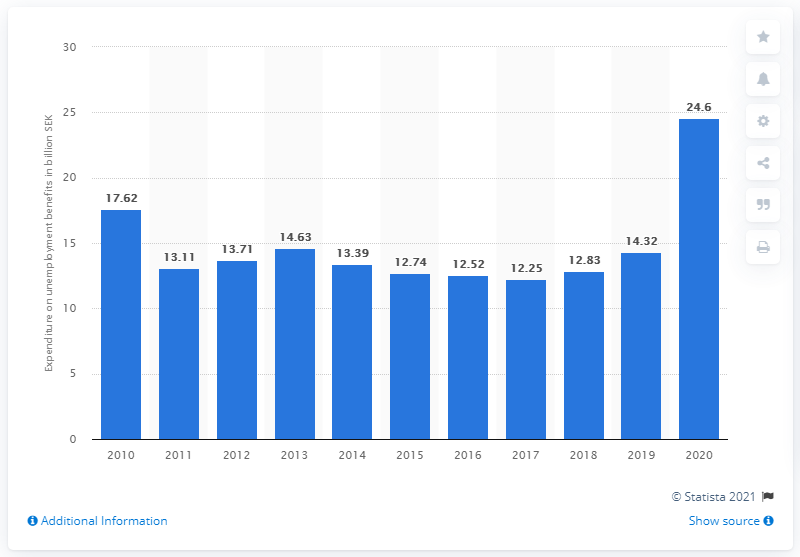Mention a couple of crucial points in this snapshot. In 2020, the annual amount paid out to unemployed individuals in Sweden was 24,600 SEK. 